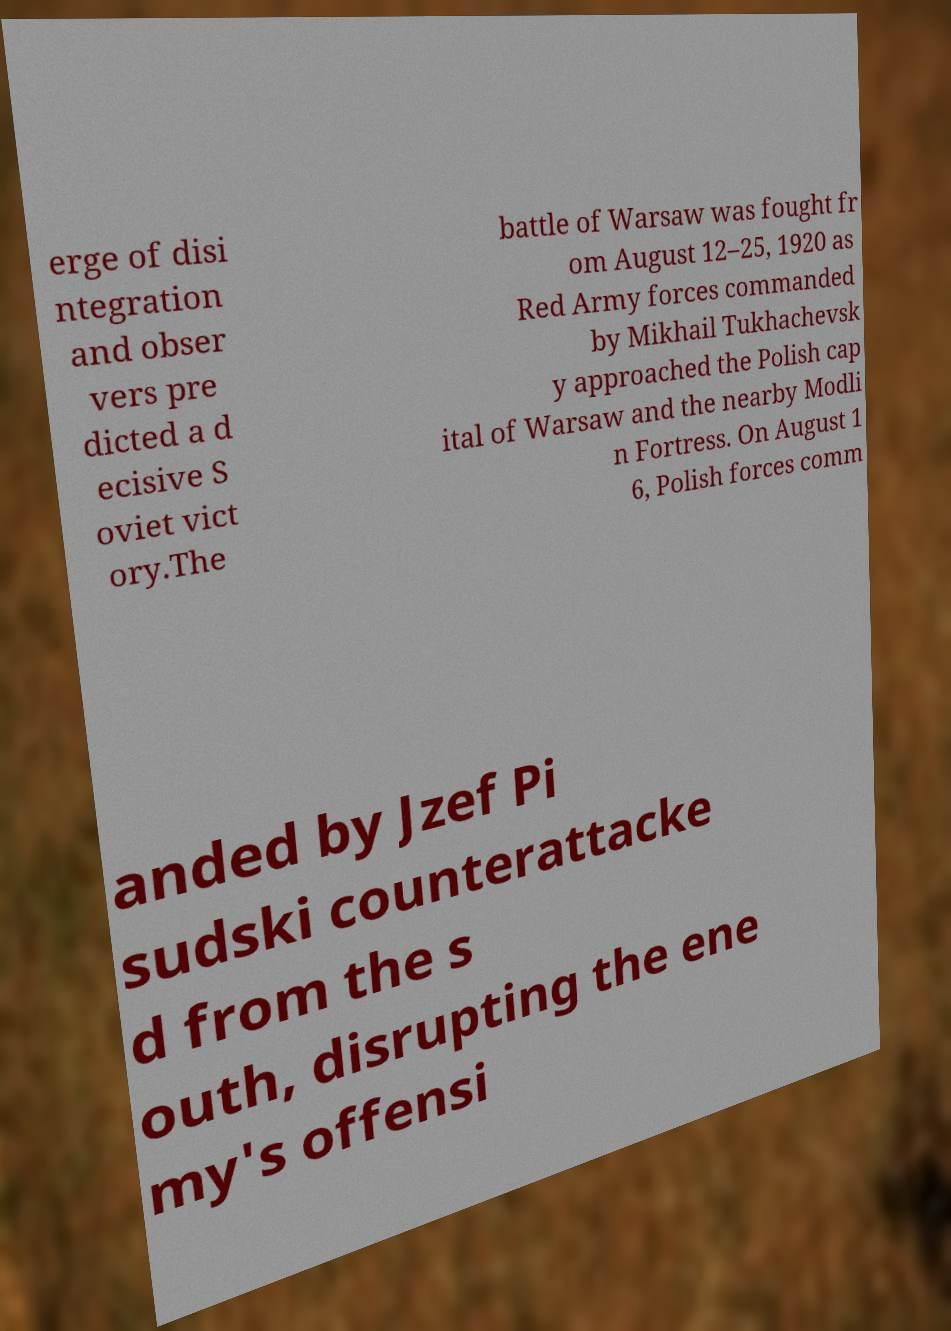There's text embedded in this image that I need extracted. Can you transcribe it verbatim? erge of disi ntegration and obser vers pre dicted a d ecisive S oviet vict ory.The battle of Warsaw was fought fr om August 12–25, 1920 as Red Army forces commanded by Mikhail Tukhachevsk y approached the Polish cap ital of Warsaw and the nearby Modli n Fortress. On August 1 6, Polish forces comm anded by Jzef Pi sudski counterattacke d from the s outh, disrupting the ene my's offensi 